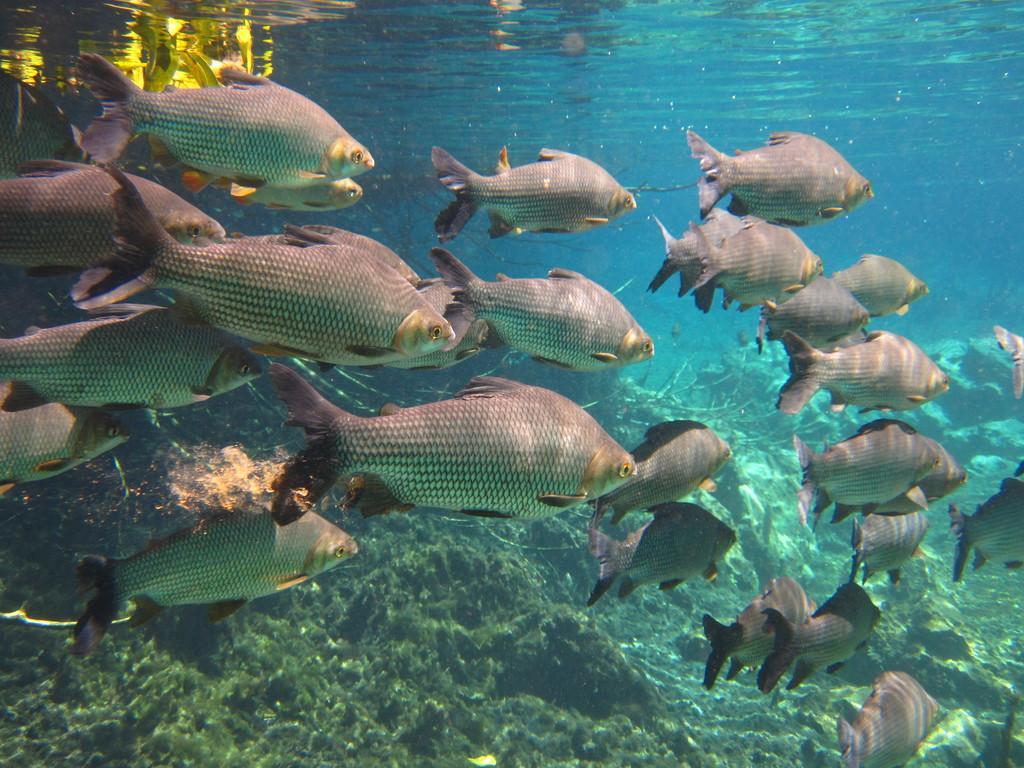Could you give a brief overview of what you see in this image? In this image there are fishes are visible below the surface of the water. 